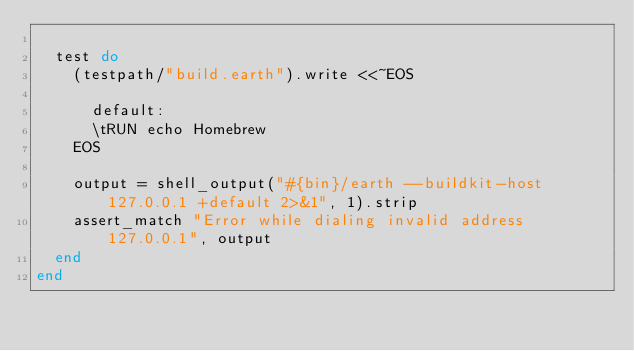<code> <loc_0><loc_0><loc_500><loc_500><_Ruby_>
  test do
    (testpath/"build.earth").write <<~EOS

      default:
      \tRUN echo Homebrew
    EOS

    output = shell_output("#{bin}/earth --buildkit-host 127.0.0.1 +default 2>&1", 1).strip
    assert_match "Error while dialing invalid address 127.0.0.1", output
  end
end
</code> 